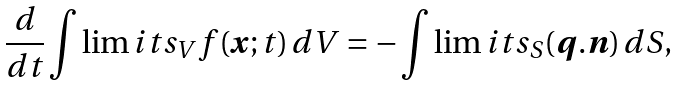Convert formula to latex. <formula><loc_0><loc_0><loc_500><loc_500>\frac { d } { d t } \int \lim i t s _ { V } f ( { \boldsymbol x } ; t ) \, d V = - \int \lim i t s _ { S } ( { \boldsymbol q } . { \boldsymbol n } ) \, d S ,</formula> 